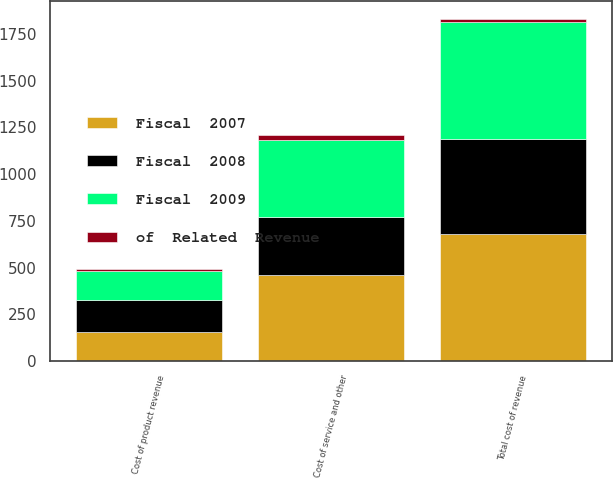Convert chart to OTSL. <chart><loc_0><loc_0><loc_500><loc_500><stacked_bar_chart><ecel><fcel>Cost of product revenue<fcel>Cost of service and other<fcel>Total cost of revenue<nl><fcel>Fiscal  2007<fcel>157.2<fcel>458.5<fcel>676.9<nl><fcel>of  Related  Revenue<fcel>11<fcel>25<fcel>21<nl><fcel>Fiscal  2009<fcel>154.1<fcel>414.1<fcel>624.2<nl><fcel>Fiscal  2008<fcel>169.1<fcel>309.4<fcel>509.4<nl></chart> 